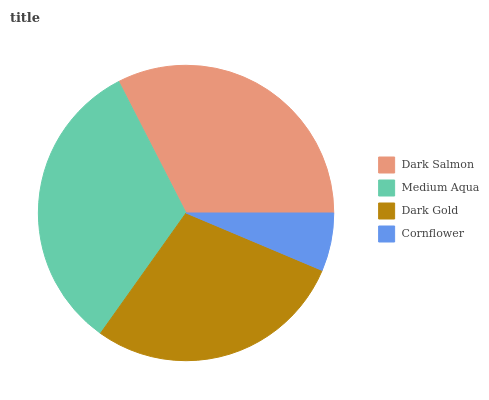Is Cornflower the minimum?
Answer yes or no. Yes. Is Medium Aqua the maximum?
Answer yes or no. Yes. Is Dark Gold the minimum?
Answer yes or no. No. Is Dark Gold the maximum?
Answer yes or no. No. Is Medium Aqua greater than Dark Gold?
Answer yes or no. Yes. Is Dark Gold less than Medium Aqua?
Answer yes or no. Yes. Is Dark Gold greater than Medium Aqua?
Answer yes or no. No. Is Medium Aqua less than Dark Gold?
Answer yes or no. No. Is Dark Salmon the high median?
Answer yes or no. Yes. Is Dark Gold the low median?
Answer yes or no. Yes. Is Medium Aqua the high median?
Answer yes or no. No. Is Cornflower the low median?
Answer yes or no. No. 